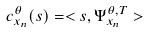Convert formula to latex. <formula><loc_0><loc_0><loc_500><loc_500>c _ { x _ { n } } ^ { \theta } ( s ) = < s , \Psi _ { x _ { n } } ^ { \theta , T } ></formula> 